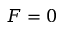<formula> <loc_0><loc_0><loc_500><loc_500>F = 0</formula> 